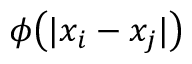<formula> <loc_0><loc_0><loc_500><loc_500>\phi \left ( | x _ { i } - x _ { j } | \right )</formula> 